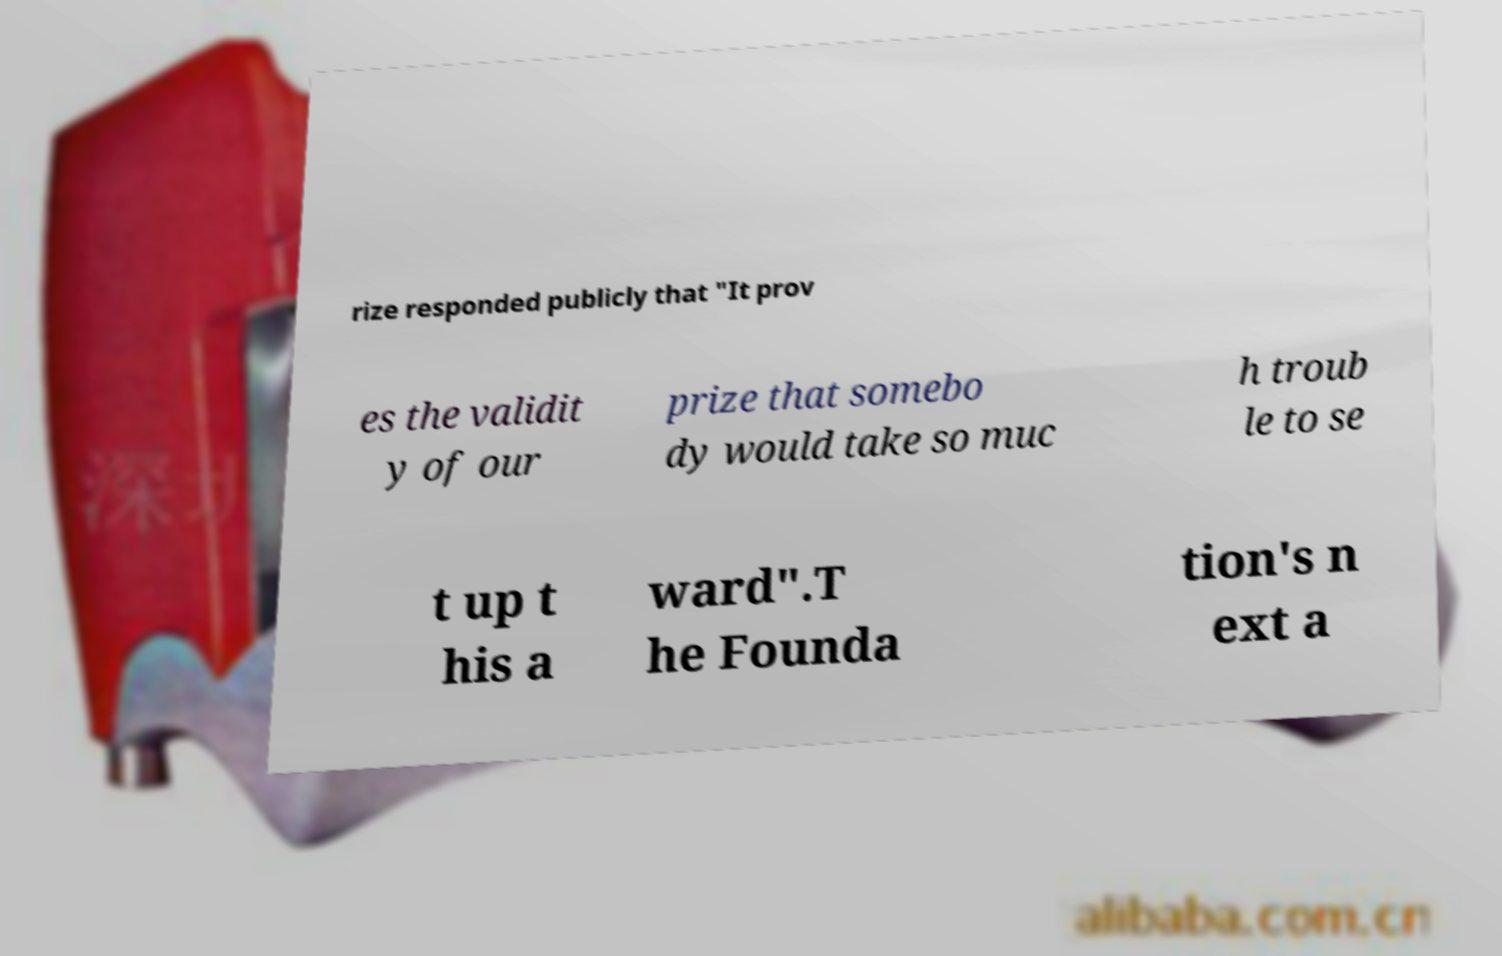Can you accurately transcribe the text from the provided image for me? rize responded publicly that "It prov es the validit y of our prize that somebo dy would take so muc h troub le to se t up t his a ward".T he Founda tion's n ext a 